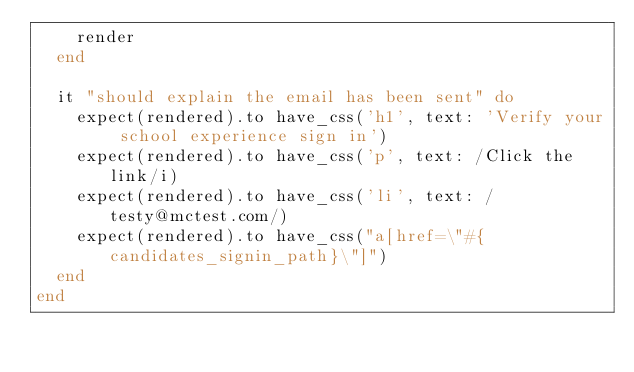<code> <loc_0><loc_0><loc_500><loc_500><_Ruby_>    render
  end

  it "should explain the email has been sent" do
    expect(rendered).to have_css('h1', text: 'Verify your school experience sign in')
    expect(rendered).to have_css('p', text: /Click the link/i)
    expect(rendered).to have_css('li', text: /testy@mctest.com/)
    expect(rendered).to have_css("a[href=\"#{candidates_signin_path}\"]")
  end
end
</code> 